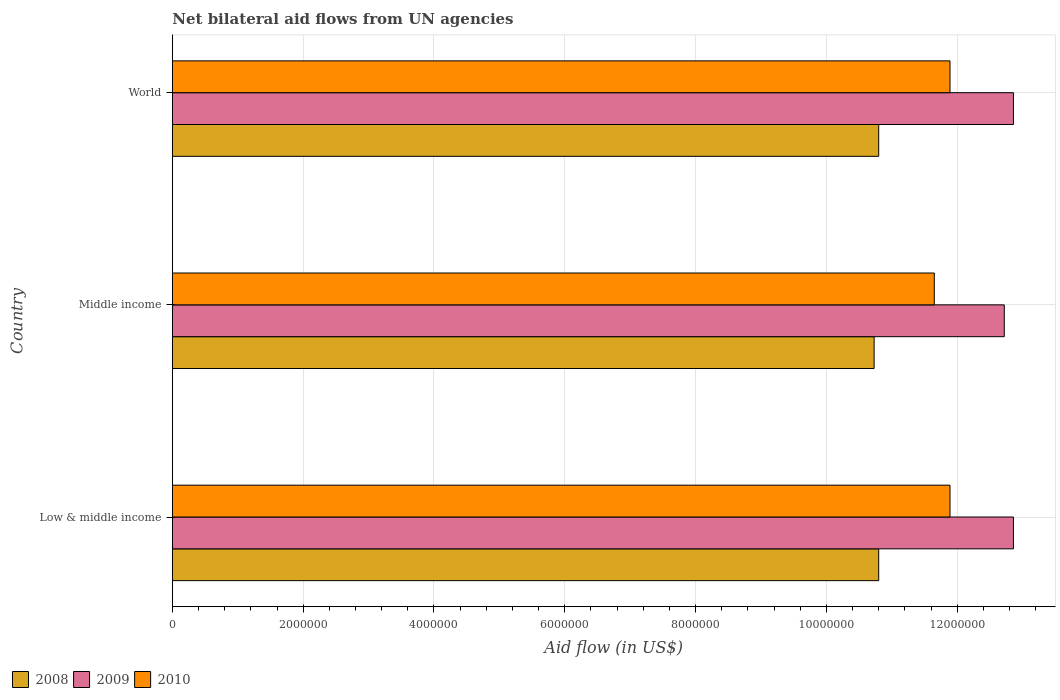How many different coloured bars are there?
Provide a succinct answer. 3. How many groups of bars are there?
Make the answer very short. 3. How many bars are there on the 1st tick from the top?
Your answer should be compact. 3. How many bars are there on the 1st tick from the bottom?
Offer a terse response. 3. What is the label of the 3rd group of bars from the top?
Offer a terse response. Low & middle income. What is the net bilateral aid flow in 2008 in Middle income?
Keep it short and to the point. 1.07e+07. Across all countries, what is the maximum net bilateral aid flow in 2009?
Ensure brevity in your answer.  1.29e+07. Across all countries, what is the minimum net bilateral aid flow in 2009?
Offer a very short reply. 1.27e+07. In which country was the net bilateral aid flow in 2010 minimum?
Provide a succinct answer. Middle income. What is the total net bilateral aid flow in 2008 in the graph?
Your response must be concise. 3.23e+07. What is the difference between the net bilateral aid flow in 2008 in Low & middle income and that in World?
Offer a very short reply. 0. What is the difference between the net bilateral aid flow in 2009 in Middle income and the net bilateral aid flow in 2010 in World?
Provide a short and direct response. 8.30e+05. What is the average net bilateral aid flow in 2009 per country?
Provide a short and direct response. 1.28e+07. What is the difference between the net bilateral aid flow in 2008 and net bilateral aid flow in 2009 in Middle income?
Give a very brief answer. -1.99e+06. What is the ratio of the net bilateral aid flow in 2010 in Low & middle income to that in World?
Your answer should be very brief. 1. Is the net bilateral aid flow in 2009 in Middle income less than that in World?
Give a very brief answer. Yes. Is the difference between the net bilateral aid flow in 2008 in Low & middle income and World greater than the difference between the net bilateral aid flow in 2009 in Low & middle income and World?
Offer a very short reply. No. What is the difference between the highest and the lowest net bilateral aid flow in 2008?
Your answer should be compact. 7.00e+04. What does the 2nd bar from the bottom in Middle income represents?
Provide a short and direct response. 2009. How many bars are there?
Your response must be concise. 9. What is the difference between two consecutive major ticks on the X-axis?
Offer a terse response. 2.00e+06. Are the values on the major ticks of X-axis written in scientific E-notation?
Keep it short and to the point. No. How are the legend labels stacked?
Your answer should be compact. Horizontal. What is the title of the graph?
Keep it short and to the point. Net bilateral aid flows from UN agencies. What is the label or title of the X-axis?
Your answer should be compact. Aid flow (in US$). What is the Aid flow (in US$) of 2008 in Low & middle income?
Provide a short and direct response. 1.08e+07. What is the Aid flow (in US$) in 2009 in Low & middle income?
Give a very brief answer. 1.29e+07. What is the Aid flow (in US$) in 2010 in Low & middle income?
Make the answer very short. 1.19e+07. What is the Aid flow (in US$) in 2008 in Middle income?
Provide a short and direct response. 1.07e+07. What is the Aid flow (in US$) of 2009 in Middle income?
Keep it short and to the point. 1.27e+07. What is the Aid flow (in US$) in 2010 in Middle income?
Keep it short and to the point. 1.16e+07. What is the Aid flow (in US$) of 2008 in World?
Provide a succinct answer. 1.08e+07. What is the Aid flow (in US$) in 2009 in World?
Your answer should be very brief. 1.29e+07. What is the Aid flow (in US$) in 2010 in World?
Your answer should be very brief. 1.19e+07. Across all countries, what is the maximum Aid flow (in US$) of 2008?
Offer a terse response. 1.08e+07. Across all countries, what is the maximum Aid flow (in US$) in 2009?
Give a very brief answer. 1.29e+07. Across all countries, what is the maximum Aid flow (in US$) of 2010?
Offer a very short reply. 1.19e+07. Across all countries, what is the minimum Aid flow (in US$) of 2008?
Offer a terse response. 1.07e+07. Across all countries, what is the minimum Aid flow (in US$) in 2009?
Provide a succinct answer. 1.27e+07. Across all countries, what is the minimum Aid flow (in US$) of 2010?
Your answer should be compact. 1.16e+07. What is the total Aid flow (in US$) in 2008 in the graph?
Your response must be concise. 3.23e+07. What is the total Aid flow (in US$) in 2009 in the graph?
Provide a succinct answer. 3.84e+07. What is the total Aid flow (in US$) of 2010 in the graph?
Give a very brief answer. 3.54e+07. What is the difference between the Aid flow (in US$) in 2008 in Low & middle income and that in Middle income?
Your response must be concise. 7.00e+04. What is the difference between the Aid flow (in US$) in 2008 in Low & middle income and that in World?
Offer a terse response. 0. What is the difference between the Aid flow (in US$) of 2008 in Middle income and that in World?
Give a very brief answer. -7.00e+04. What is the difference between the Aid flow (in US$) in 2008 in Low & middle income and the Aid flow (in US$) in 2009 in Middle income?
Provide a succinct answer. -1.92e+06. What is the difference between the Aid flow (in US$) of 2008 in Low & middle income and the Aid flow (in US$) of 2010 in Middle income?
Provide a short and direct response. -8.50e+05. What is the difference between the Aid flow (in US$) of 2009 in Low & middle income and the Aid flow (in US$) of 2010 in Middle income?
Your response must be concise. 1.21e+06. What is the difference between the Aid flow (in US$) of 2008 in Low & middle income and the Aid flow (in US$) of 2009 in World?
Your answer should be very brief. -2.06e+06. What is the difference between the Aid flow (in US$) in 2008 in Low & middle income and the Aid flow (in US$) in 2010 in World?
Offer a very short reply. -1.09e+06. What is the difference between the Aid flow (in US$) in 2009 in Low & middle income and the Aid flow (in US$) in 2010 in World?
Keep it short and to the point. 9.70e+05. What is the difference between the Aid flow (in US$) of 2008 in Middle income and the Aid flow (in US$) of 2009 in World?
Ensure brevity in your answer.  -2.13e+06. What is the difference between the Aid flow (in US$) of 2008 in Middle income and the Aid flow (in US$) of 2010 in World?
Provide a succinct answer. -1.16e+06. What is the difference between the Aid flow (in US$) of 2009 in Middle income and the Aid flow (in US$) of 2010 in World?
Offer a terse response. 8.30e+05. What is the average Aid flow (in US$) of 2008 per country?
Your response must be concise. 1.08e+07. What is the average Aid flow (in US$) of 2009 per country?
Ensure brevity in your answer.  1.28e+07. What is the average Aid flow (in US$) in 2010 per country?
Provide a succinct answer. 1.18e+07. What is the difference between the Aid flow (in US$) of 2008 and Aid flow (in US$) of 2009 in Low & middle income?
Keep it short and to the point. -2.06e+06. What is the difference between the Aid flow (in US$) of 2008 and Aid flow (in US$) of 2010 in Low & middle income?
Offer a very short reply. -1.09e+06. What is the difference between the Aid flow (in US$) of 2009 and Aid flow (in US$) of 2010 in Low & middle income?
Your response must be concise. 9.70e+05. What is the difference between the Aid flow (in US$) of 2008 and Aid flow (in US$) of 2009 in Middle income?
Your response must be concise. -1.99e+06. What is the difference between the Aid flow (in US$) of 2008 and Aid flow (in US$) of 2010 in Middle income?
Offer a very short reply. -9.20e+05. What is the difference between the Aid flow (in US$) in 2009 and Aid flow (in US$) in 2010 in Middle income?
Offer a very short reply. 1.07e+06. What is the difference between the Aid flow (in US$) of 2008 and Aid flow (in US$) of 2009 in World?
Offer a very short reply. -2.06e+06. What is the difference between the Aid flow (in US$) in 2008 and Aid flow (in US$) in 2010 in World?
Give a very brief answer. -1.09e+06. What is the difference between the Aid flow (in US$) in 2009 and Aid flow (in US$) in 2010 in World?
Your response must be concise. 9.70e+05. What is the ratio of the Aid flow (in US$) of 2009 in Low & middle income to that in Middle income?
Provide a succinct answer. 1.01. What is the ratio of the Aid flow (in US$) in 2010 in Low & middle income to that in Middle income?
Your answer should be very brief. 1.02. What is the ratio of the Aid flow (in US$) of 2008 in Low & middle income to that in World?
Ensure brevity in your answer.  1. What is the ratio of the Aid flow (in US$) of 2008 in Middle income to that in World?
Keep it short and to the point. 0.99. What is the ratio of the Aid flow (in US$) of 2009 in Middle income to that in World?
Your answer should be compact. 0.99. What is the ratio of the Aid flow (in US$) in 2010 in Middle income to that in World?
Your answer should be very brief. 0.98. What is the difference between the highest and the second highest Aid flow (in US$) in 2008?
Provide a succinct answer. 0. What is the difference between the highest and the second highest Aid flow (in US$) in 2009?
Give a very brief answer. 0. What is the difference between the highest and the second highest Aid flow (in US$) in 2010?
Provide a succinct answer. 0. What is the difference between the highest and the lowest Aid flow (in US$) in 2008?
Your answer should be very brief. 7.00e+04. What is the difference between the highest and the lowest Aid flow (in US$) in 2010?
Give a very brief answer. 2.40e+05. 